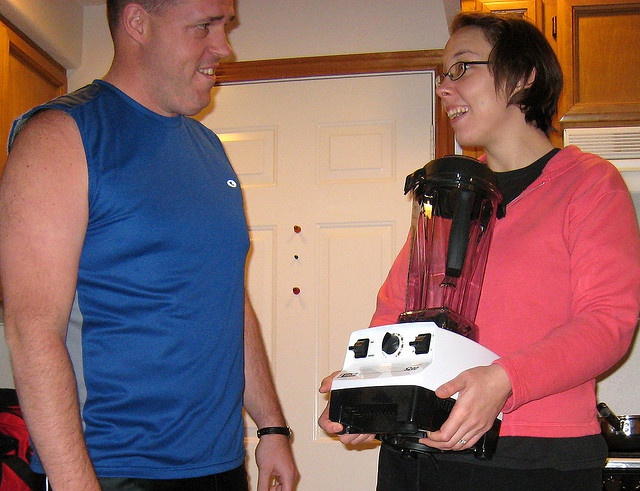Describe the objects in this image and their specific colors. I can see people in brown, blue, navy, and darkblue tones, people in brown, salmon, and black tones, and oven in brown, black, white, darkgray, and tan tones in this image. 